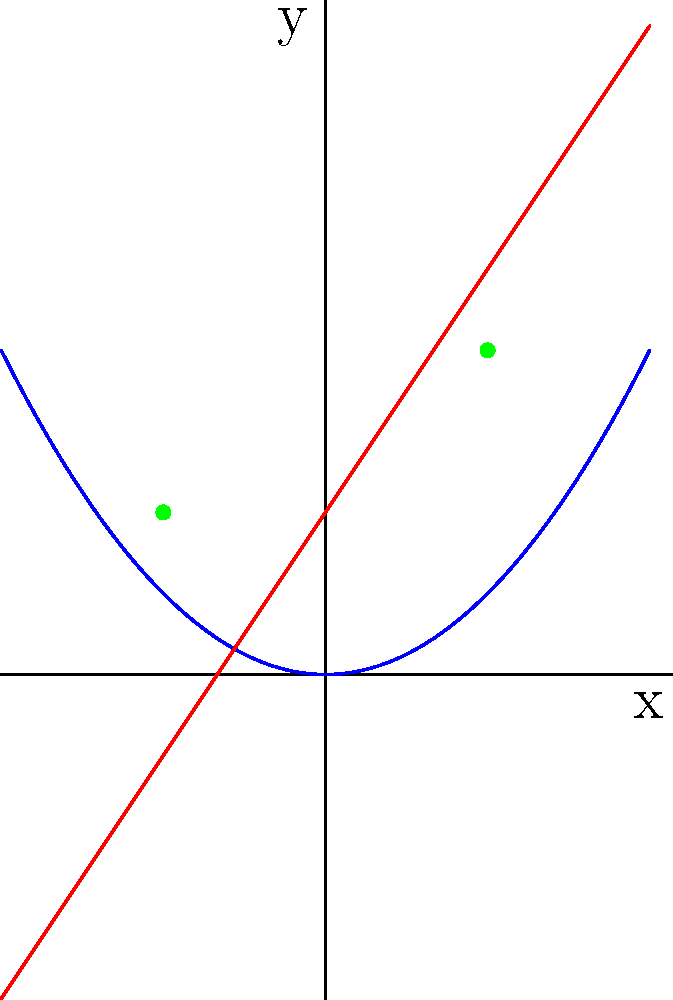In a philosophical bakery, a croissant's arc is represented by the parabola $y = 0.5x^2$, while a knife cutting through it follows the line $y = 1.5x + 1$. At what points does the knife intersect the croissant, and what do these intersection points symbolize in the baker's philosophy of creation and destruction? To find the intersection points, we need to solve the equation:

$$0.5x^2 = 1.5x + 1$$

1) Rearrange the equation:
   $$0.5x^2 - 1.5x - 1 = 0$$

2) Multiply all terms by 2 to simplify:
   $$x^2 - 3x - 2 = 0$$

3) This is a quadratic equation. We can solve it using the quadratic formula:
   $$x = \frac{-b \pm \sqrt{b^2 - 4ac}}{2a}$$
   where $a=1$, $b=-3$, and $c=-2$

4) Substituting these values:
   $$x = \frac{3 \pm \sqrt{9 - 4(1)(-2)}}{2(1)} = \frac{3 \pm \sqrt{17}}{2}$$

5) Solving:
   $$x_1 = \frac{3 + \sqrt{17}}{2} \approx 2.56$$
   $$x_2 = \frac{3 - \sqrt{17}}{2} \approx -0.56$$

6) To find the y-coordinates, substitute these x-values into either equation:
   For $x_1$: $y = 0.5(2.56)^2 \approx 3.28$
   For $x_2$: $y = 0.5(-0.56)^2 \approx 0.16$

Therefore, the intersection points are approximately (-0.56, 0.16) and (2.56, 3.28).

Philosophically, these points represent the moments of creation (where the knife first touches the dough) and destruction (where it completes its cut), symbolizing the cyclical nature of existence in the baker's craft.
Answer: (-0.56, 0.16) and (2.56, 3.28) 